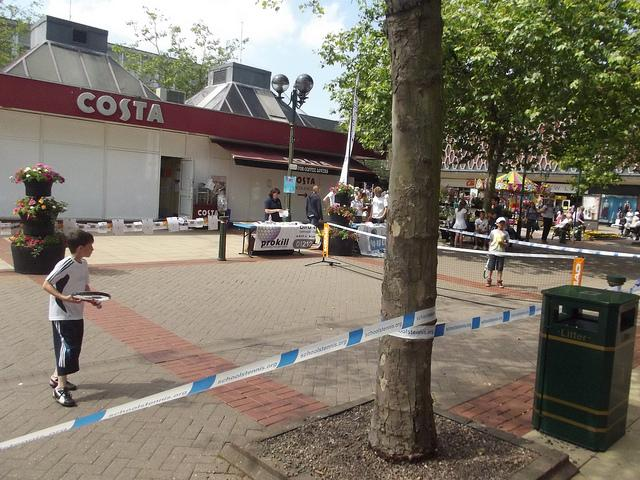What is the boy in the foreground doing?

Choices:
A) eating lunch
B) playing tennis
C) cleaning park
D) threatening others playing tennis 